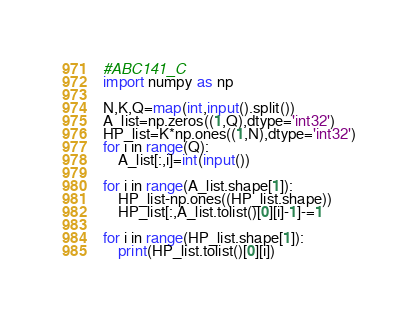<code> <loc_0><loc_0><loc_500><loc_500><_Python_>#ABC141_C
import numpy as np

N,K,Q=map(int,input().split())
A_list=np.zeros((1,Q),dtype='int32')
HP_list=K*np.ones((1,N),dtype='int32')
for i in range(Q):
    A_list[:,i]=int(input())

for i in range(A_list.shape[1]):
    HP_list-np.ones((HP_list.shape))
    HP_list[:,A_list.tolist()[0][i]-1]-=1

for i in range(HP_list.shape[1]):
    print(HP_list.tolist()[0][i])</code> 